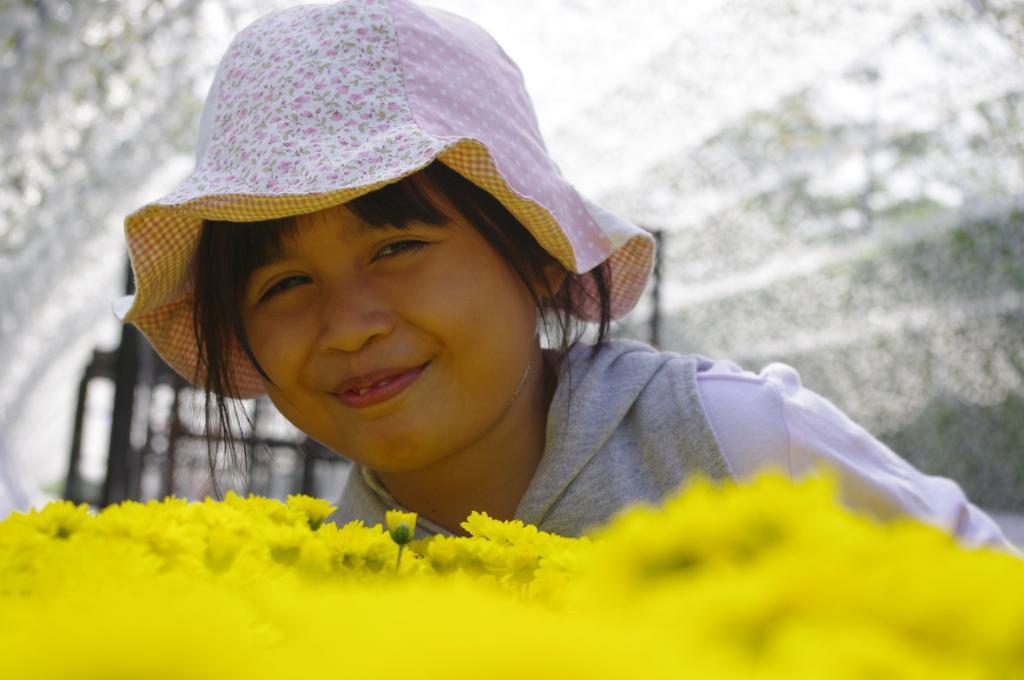In one or two sentences, can you explain what this image depicts? In the foreground of this picture,there are yellow colored flowers and behind it there is a girl wearing hat and having smile on her face and the background is blurred. 